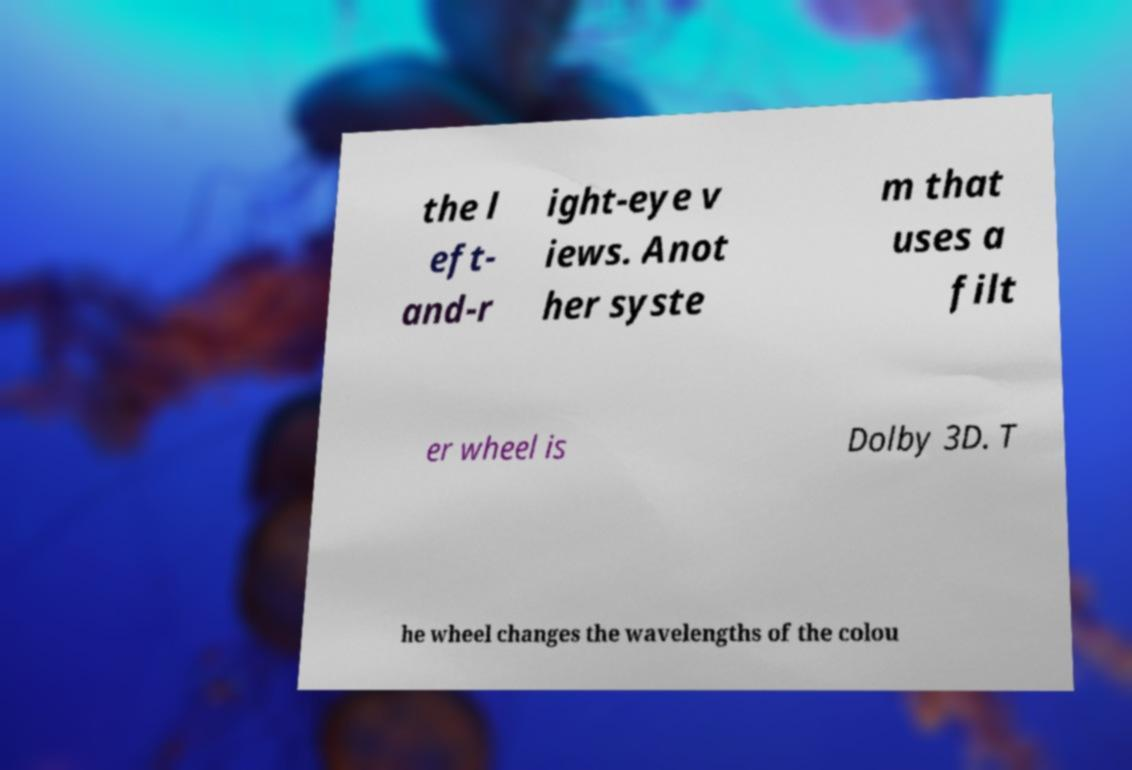Can you read and provide the text displayed in the image?This photo seems to have some interesting text. Can you extract and type it out for me? the l eft- and-r ight-eye v iews. Anot her syste m that uses a filt er wheel is Dolby 3D. T he wheel changes the wavelengths of the colou 